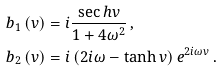<formula> <loc_0><loc_0><loc_500><loc_500>b _ { 1 } \left ( v \right ) & = i \frac { \sec h v } { 1 + 4 \omega ^ { 2 } } \, , \\ b _ { 2 } \left ( v \right ) & = i \left ( 2 i \omega - \tanh v \right ) e ^ { 2 i \omega v } \, .</formula> 